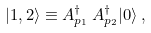<formula> <loc_0><loc_0><loc_500><loc_500>| 1 , 2 \rangle \equiv A ^ { \dagger } _ { p _ { 1 } } \, A ^ { \dagger } _ { p _ { 2 } } | 0 \rangle \, ,</formula> 